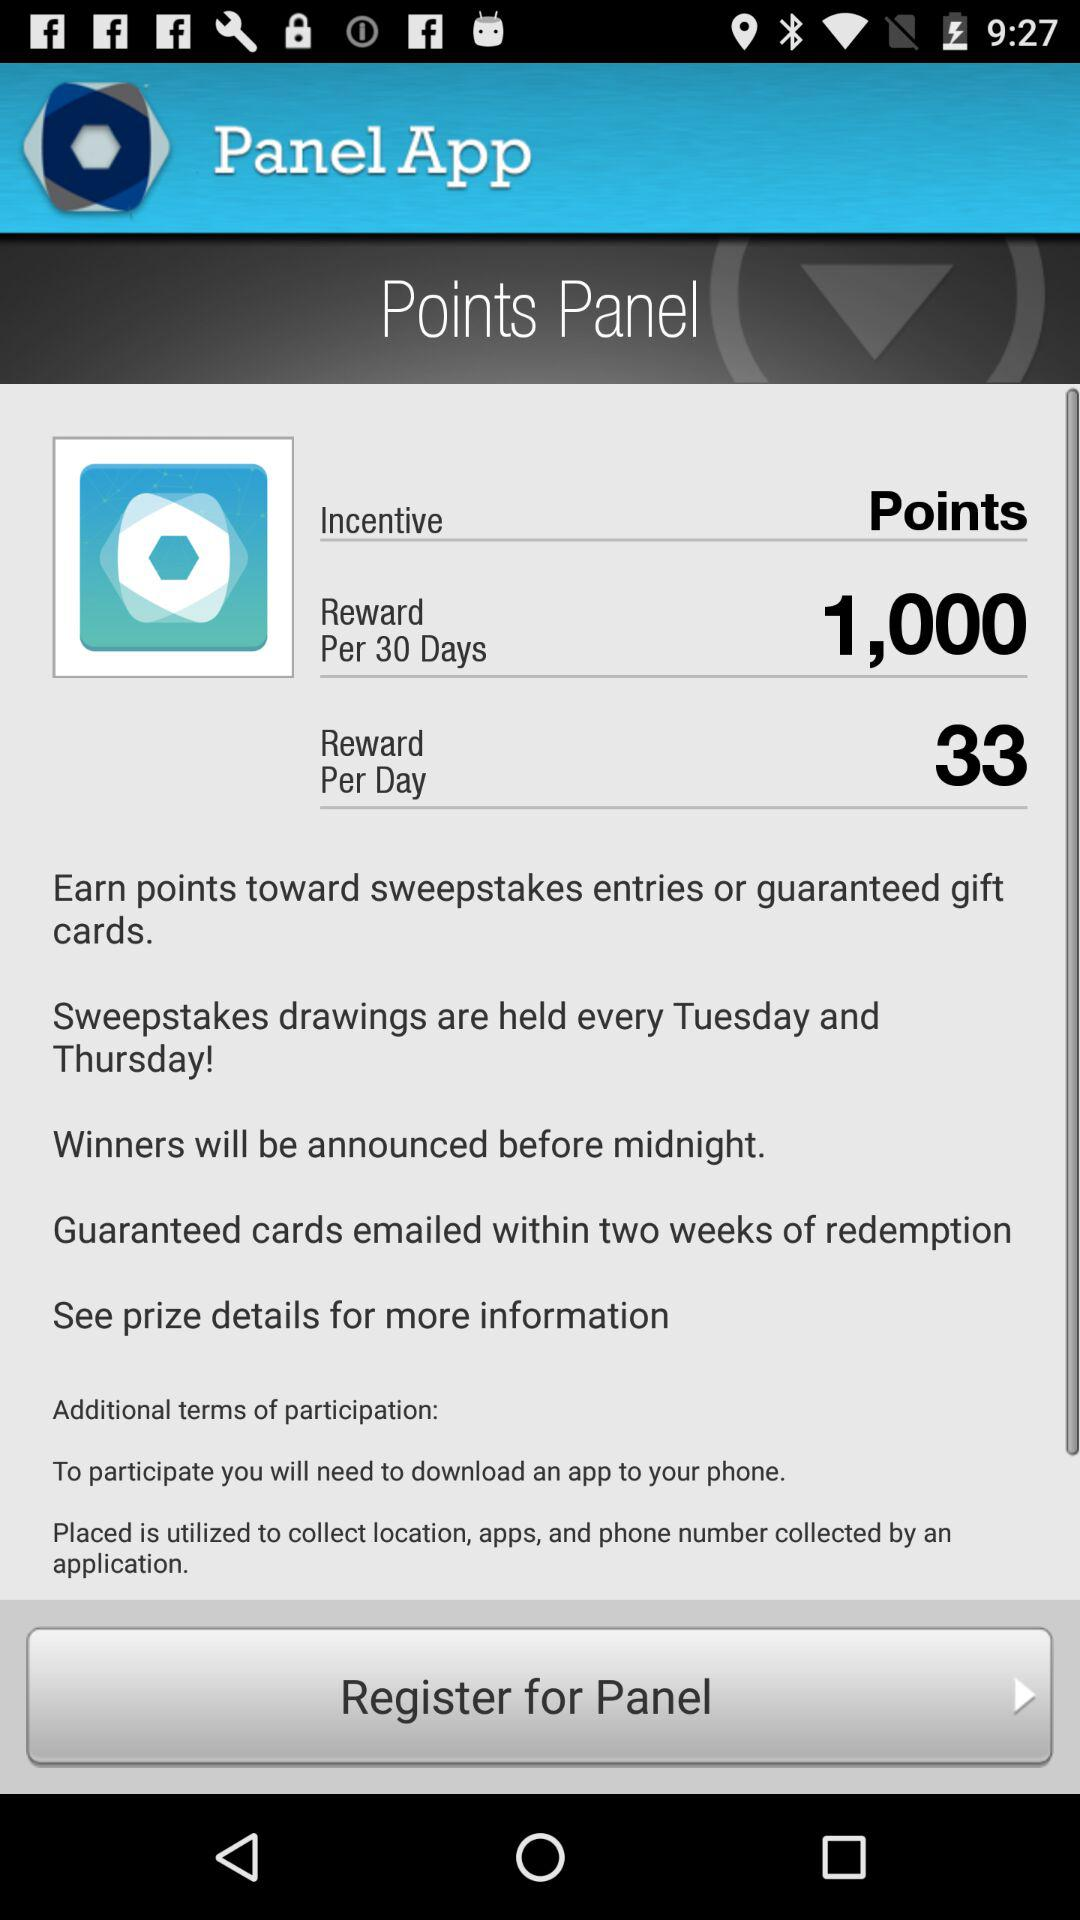How many total rewards per day are there? There are 33 total rewards per day. 